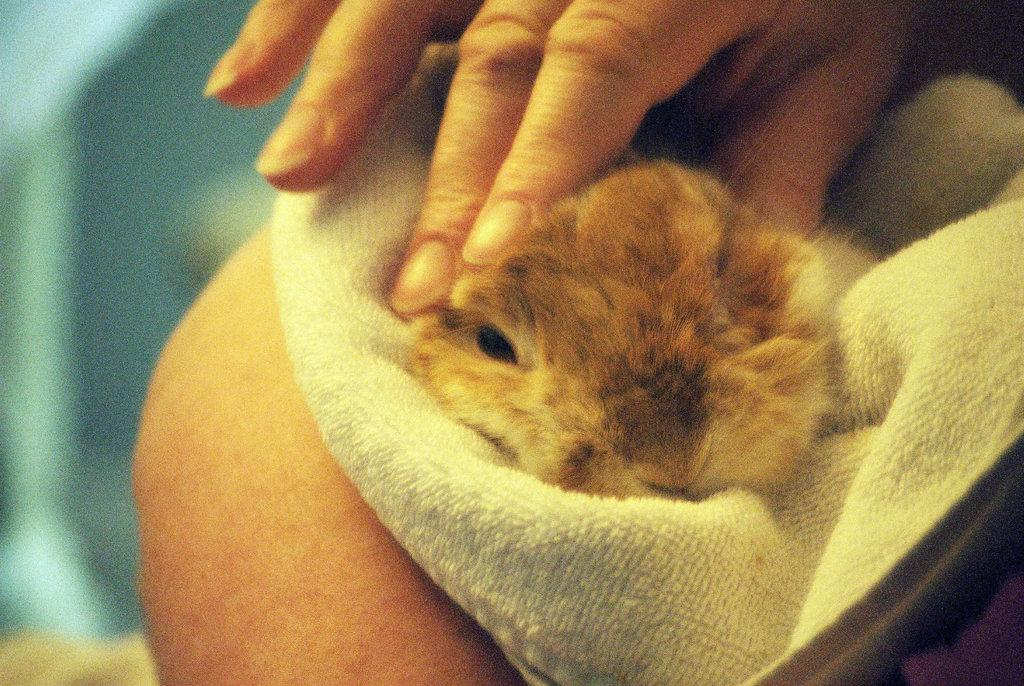What type of creature is in the picture? There is an animal in the picture. What color is the animal? The animal is brown in color. What else can be seen in the middle of the picture? There is a human hand in the middle of the picture. How would you describe the background of the image? The background of the image is blurred. How much debt does the animal owe to the laborer in the image? There is no laborer or debt present in the image; it only features an animal and a human hand. 